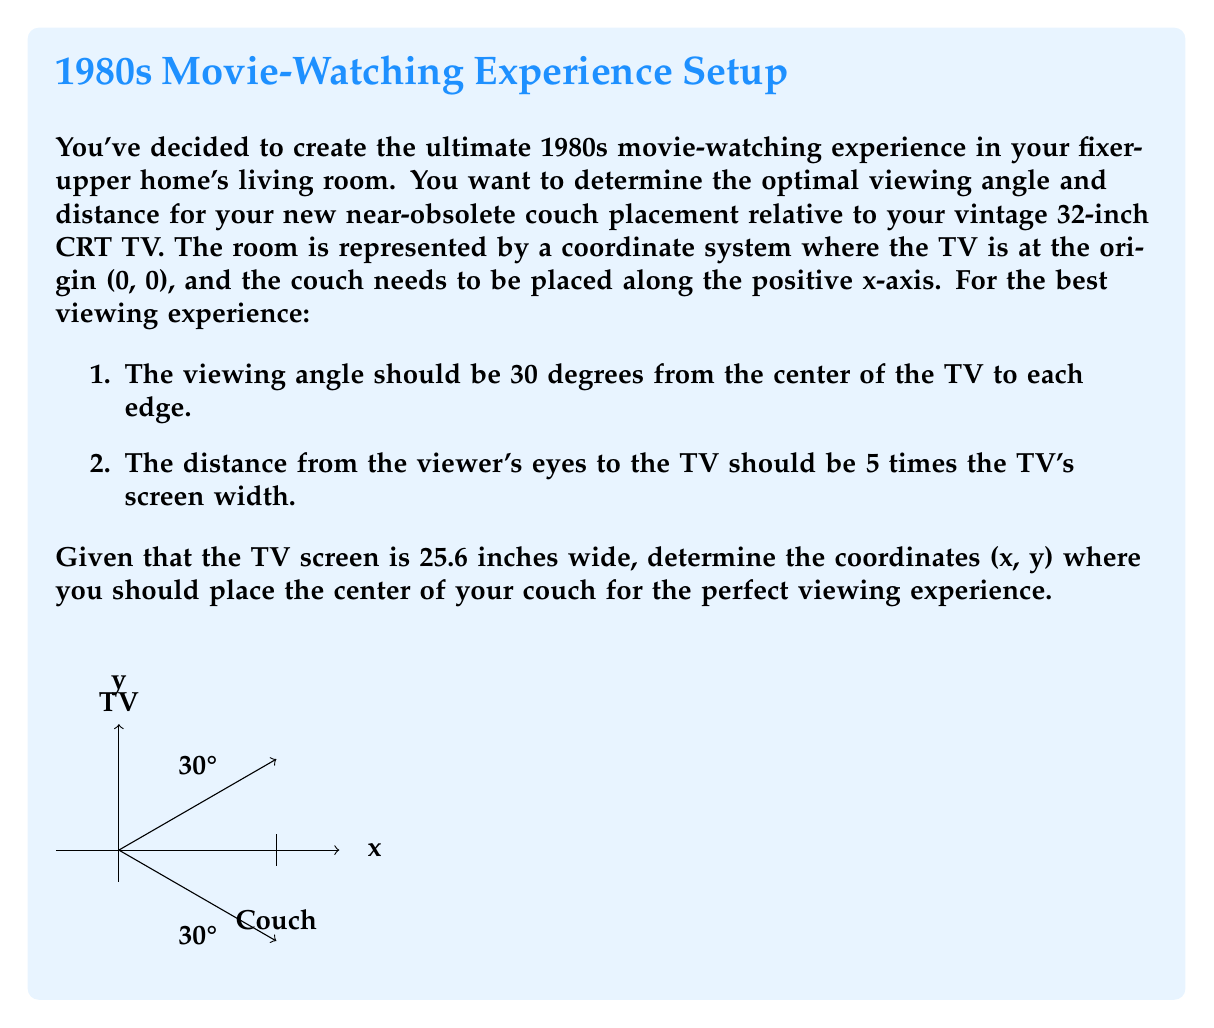Give your solution to this math problem. Let's solve this problem step by step:

1. First, we need to calculate half the width of the TV screen:
   $$\frac{25.6}{2} = 12.8 \text{ inches}$$

2. The viewing distance should be 5 times the screen width:
   $$5 \times 25.6 = 128 \text{ inches}$$

3. Now, we can set up a right triangle where:
   - The hypotenuse is the viewing distance (128 inches)
   - Half the screen width (12.8 inches) is opposite to the 30° angle
   - The x-coordinate we're looking for is adjacent to the 30° angle

4. We can use the tangent function to find the x-coordinate:
   $$\tan(30°) = \frac{12.8}{x}$$

5. Solving for x:
   $$x = \frac{12.8}{\tan(30°)} \approx 22.17 \text{ inches}$$

6. The full viewing distance (128 inches) is the hypotenuse of this right triangle. We can use the Pythagorean theorem to find the y-coordinate:

   $$128^2 = x^2 + y^2$$
   $$y = \sqrt{128^2 - x^2} \approx 0$$

7. The y-coordinate is approximately 0 because the couch needs to be placed along the positive x-axis.

Therefore, the optimal position for the center of the couch is approximately (128, 0) in our coordinate system.
Answer: (128, 0) 